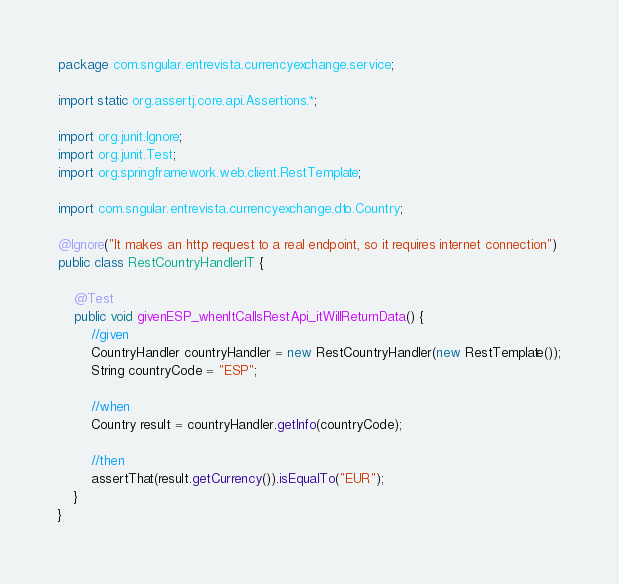<code> <loc_0><loc_0><loc_500><loc_500><_Java_>package com.sngular.entrevista.currencyexchange.service;

import static org.assertj.core.api.Assertions.*;

import org.junit.Ignore;
import org.junit.Test;
import org.springframework.web.client.RestTemplate;

import com.sngular.entrevista.currencyexchange.dto.Country;

@Ignore("It makes an http request to a real endpoint, so it requires internet connection")
public class RestCountryHandlerIT {

	@Test
	public void givenESP_whenItCallsRestApi_itWillReturnData() {
		//given
		CountryHandler countryHandler = new RestCountryHandler(new RestTemplate());
		String countryCode = "ESP";
		
		//when
		Country result = countryHandler.getInfo(countryCode);
		
		//then
		assertThat(result.getCurrency()).isEqualTo("EUR");
	}
}
</code> 